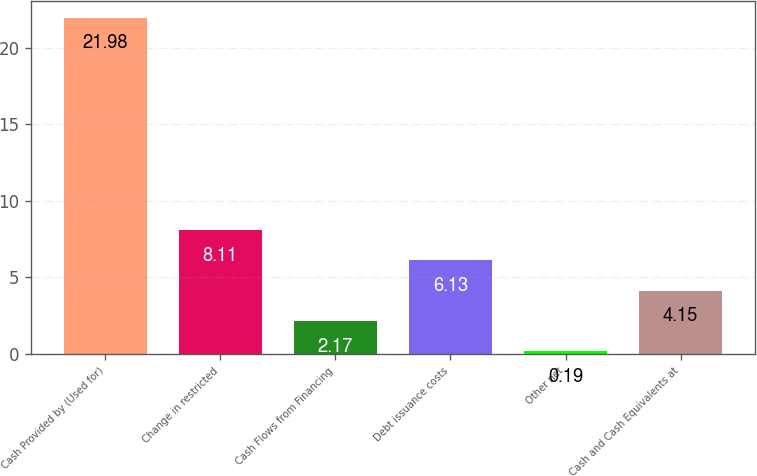<chart> <loc_0><loc_0><loc_500><loc_500><bar_chart><fcel>Cash Provided by (Used for)<fcel>Change in restricted<fcel>Cash Flows from Financing<fcel>Debt issuance costs<fcel>Other net<fcel>Cash and Cash Equivalents at<nl><fcel>21.98<fcel>8.11<fcel>2.17<fcel>6.13<fcel>0.19<fcel>4.15<nl></chart> 